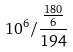Convert formula to latex. <formula><loc_0><loc_0><loc_500><loc_500>1 0 ^ { 6 } / \frac { \frac { 1 8 0 } { 6 } } { 1 9 4 }</formula> 